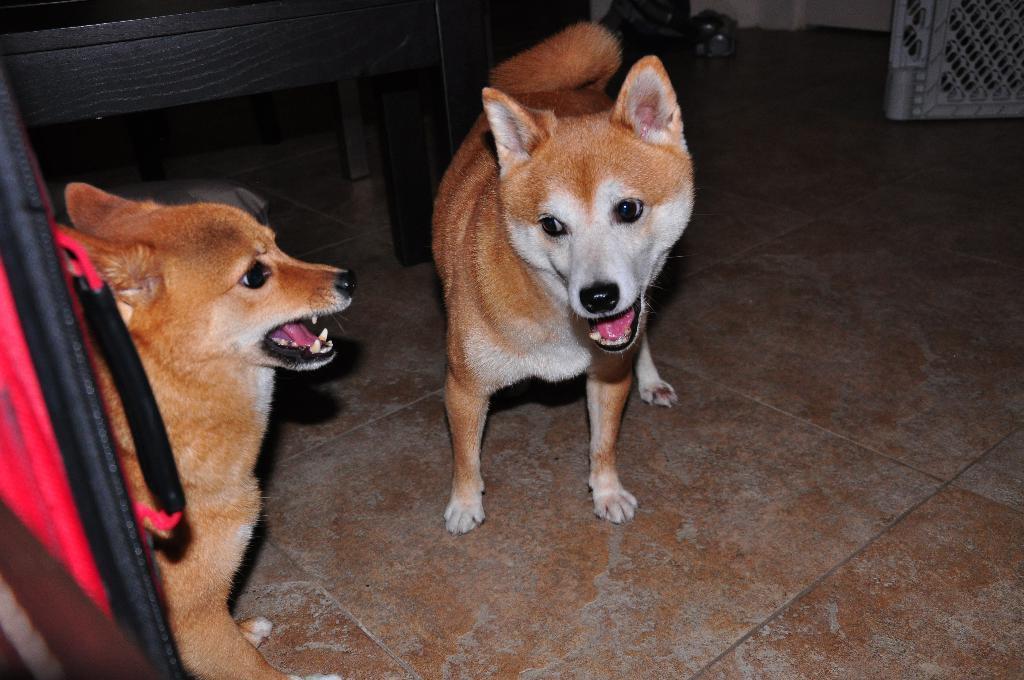Describe this image in one or two sentences. In this image I see 2 dogs over her which are of white and brown in color and I see the floor and I see the black color thing over here and I see the white color thing over here and I see the wall. 